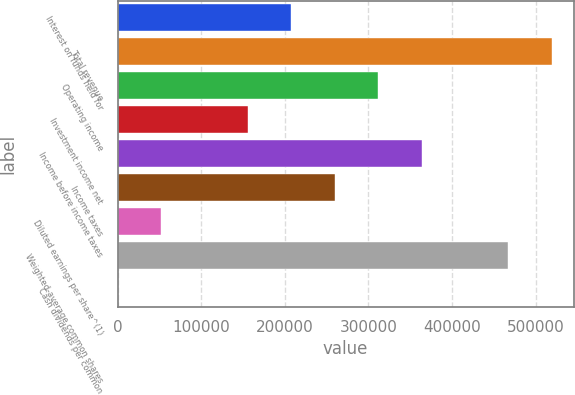Convert chart to OTSL. <chart><loc_0><loc_0><loc_500><loc_500><bar_chart><fcel>Interest on funds held for<fcel>Total revenue<fcel>Operating income<fcel>Investment income net<fcel>Income before income taxes<fcel>Income taxes<fcel>Diluted earnings per share^(1)<fcel>Weighted-average common shares<fcel>Cash dividends per common<nl><fcel>207691<fcel>519228<fcel>311537<fcel>155769<fcel>363460<fcel>259614<fcel>51923.1<fcel>467305<fcel>0.3<nl></chart> 